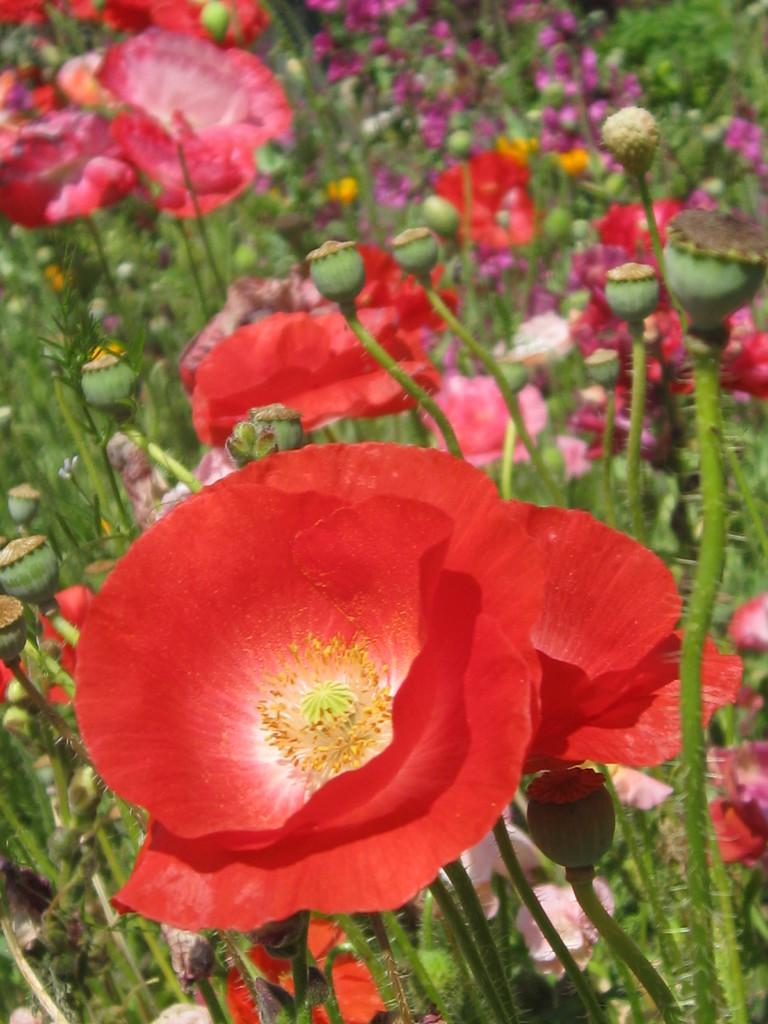What type of plants can be seen in the image? There are flowers in the image. What stage of growth are the plants in? There are buds on the plants in the image. What type of coach is present in the image? There is no coach present in the image; it features flowers and buds on plants. What type of haircut is shown on the plants in the image? There is no haircut present in the image; it features flowers and buds on plants. 